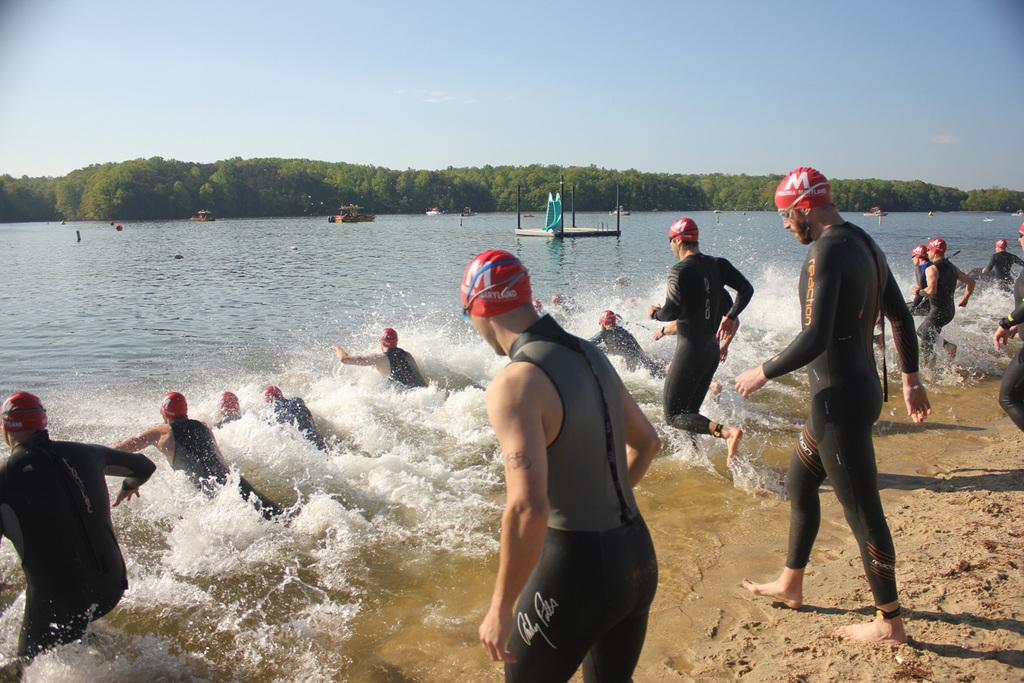How many people are in the image? There are people in the image, but the exact number is not specified. What are some people doing in the image? Some people are in the water, which suggests they might be swimming or participating in water activities. What type of watercraft can be seen in the image? There are boats in the image. What type of vegetation is present in the image? There are trees in the image. What else can be seen in the image besides people, boats, and trees? There are other objects in the image, but their specific nature is not mentioned. What is visible in the background of the image? The sky is visible in the background of the image. What type of song is being sung by the cats in the image? There are no cats present in the image, so it is not possible to determine if any song is being sung by them. 